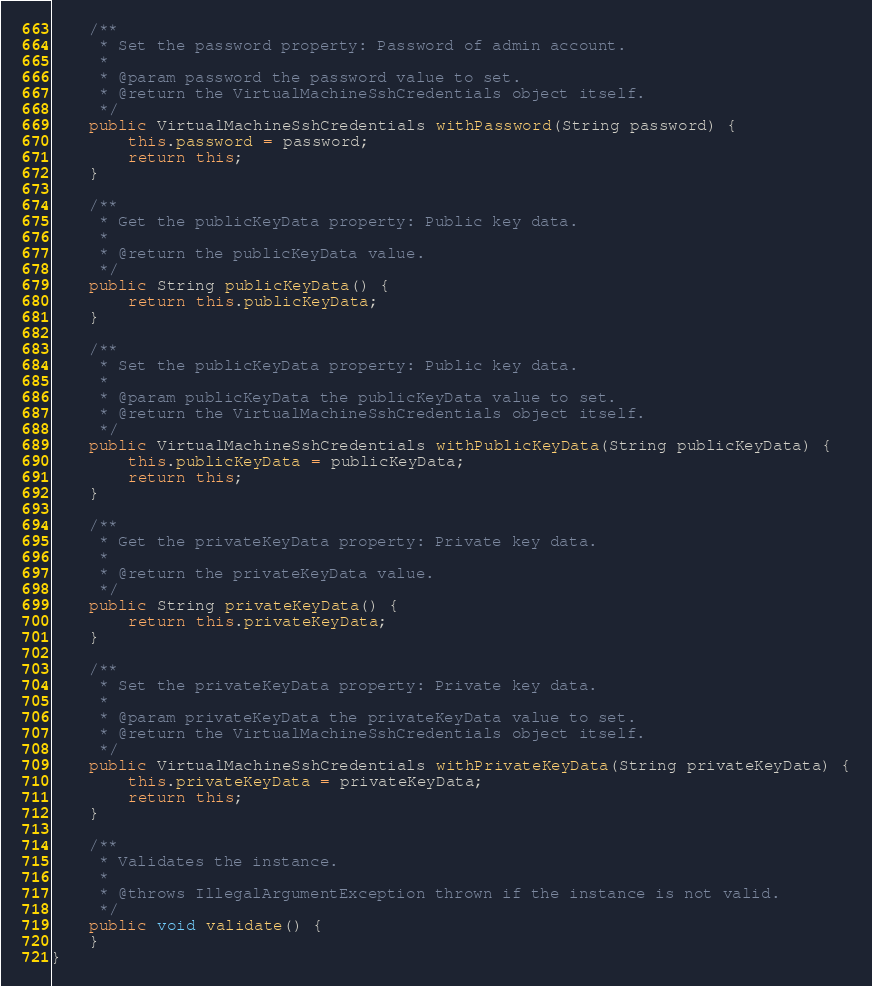Convert code to text. <code><loc_0><loc_0><loc_500><loc_500><_Java_>
    /**
     * Set the password property: Password of admin account.
     *
     * @param password the password value to set.
     * @return the VirtualMachineSshCredentials object itself.
     */
    public VirtualMachineSshCredentials withPassword(String password) {
        this.password = password;
        return this;
    }

    /**
     * Get the publicKeyData property: Public key data.
     *
     * @return the publicKeyData value.
     */
    public String publicKeyData() {
        return this.publicKeyData;
    }

    /**
     * Set the publicKeyData property: Public key data.
     *
     * @param publicKeyData the publicKeyData value to set.
     * @return the VirtualMachineSshCredentials object itself.
     */
    public VirtualMachineSshCredentials withPublicKeyData(String publicKeyData) {
        this.publicKeyData = publicKeyData;
        return this;
    }

    /**
     * Get the privateKeyData property: Private key data.
     *
     * @return the privateKeyData value.
     */
    public String privateKeyData() {
        return this.privateKeyData;
    }

    /**
     * Set the privateKeyData property: Private key data.
     *
     * @param privateKeyData the privateKeyData value to set.
     * @return the VirtualMachineSshCredentials object itself.
     */
    public VirtualMachineSshCredentials withPrivateKeyData(String privateKeyData) {
        this.privateKeyData = privateKeyData;
        return this;
    }

    /**
     * Validates the instance.
     *
     * @throws IllegalArgumentException thrown if the instance is not valid.
     */
    public void validate() {
    }
}
</code> 